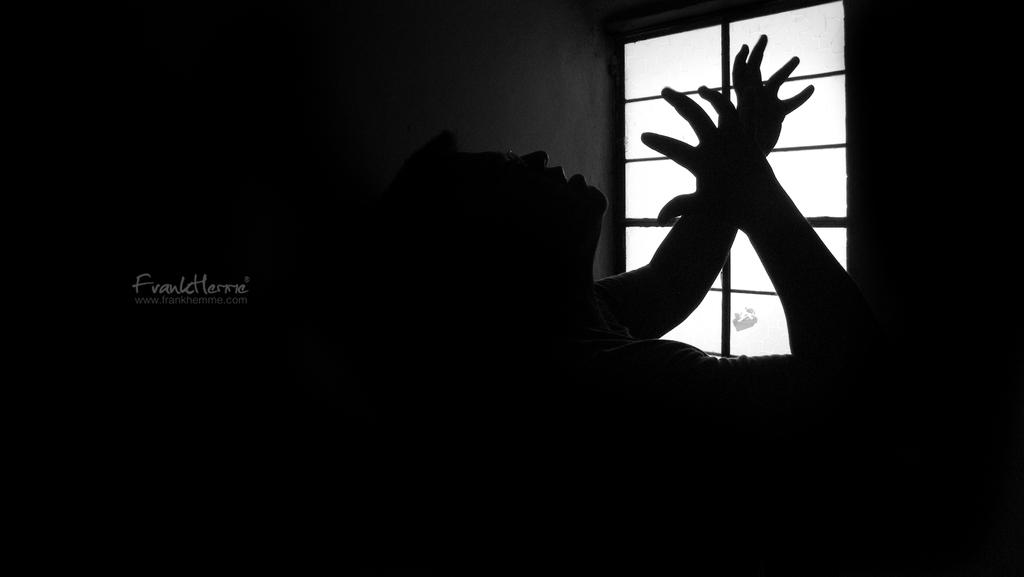What type of picture is in the image? The image contains a black and white picture of a person. What can be seen in the background of the image? There is a window visible in the background of the image. Is there any additional information or branding on the image? Yes, there is a watermark on the left side of the image. What songs can be heard playing from the mailbox in the image? There is no mailbox present in the image, and therefore no songs can be heard playing from it. 